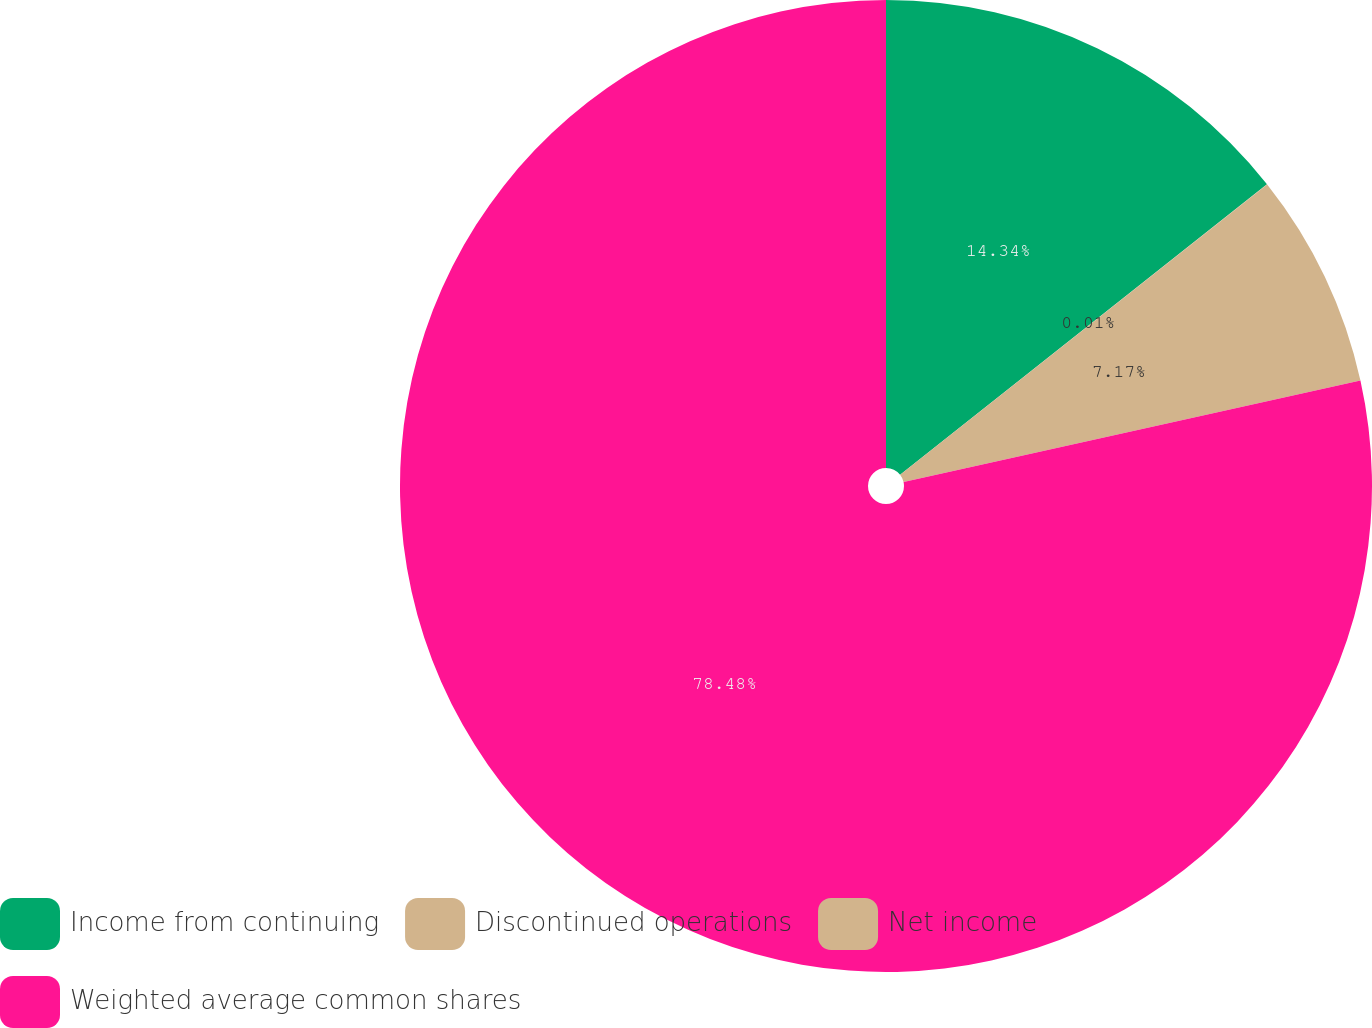Convert chart. <chart><loc_0><loc_0><loc_500><loc_500><pie_chart><fcel>Income from continuing<fcel>Discontinued operations<fcel>Net income<fcel>Weighted average common shares<nl><fcel>14.34%<fcel>0.01%<fcel>7.17%<fcel>78.48%<nl></chart> 